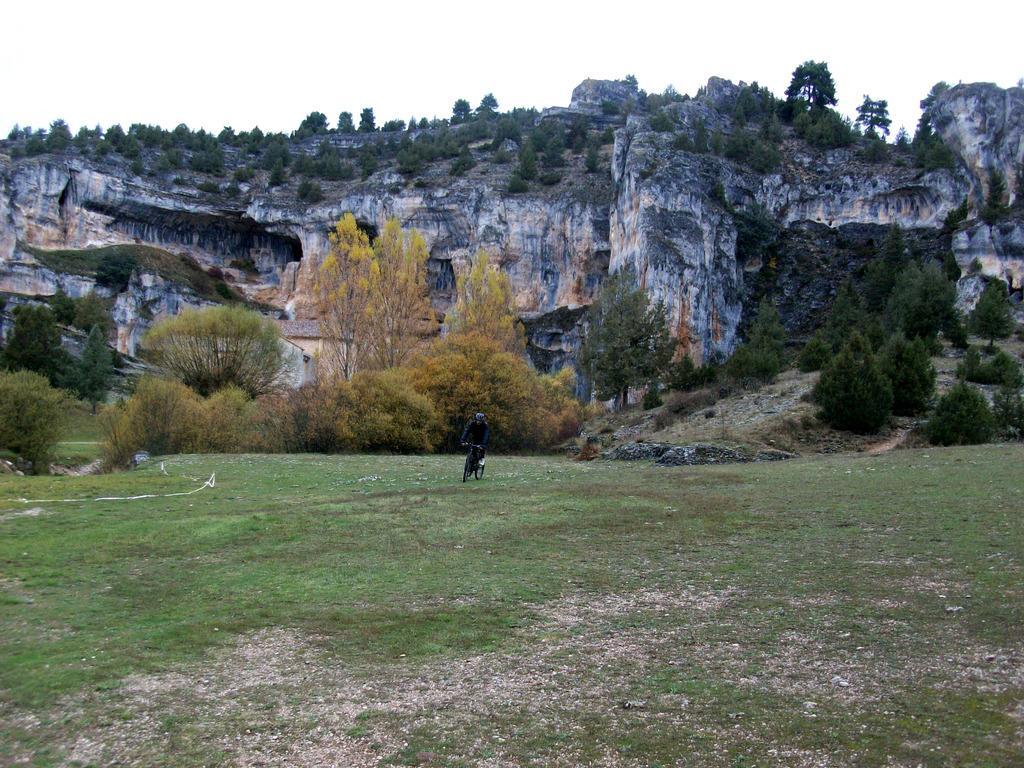Please provide a concise description of this image. In this image I can see the hill and the sky , in front of the hill I can see a person riding on bicycle on the ground and I can see trees visible in front of the hill. 